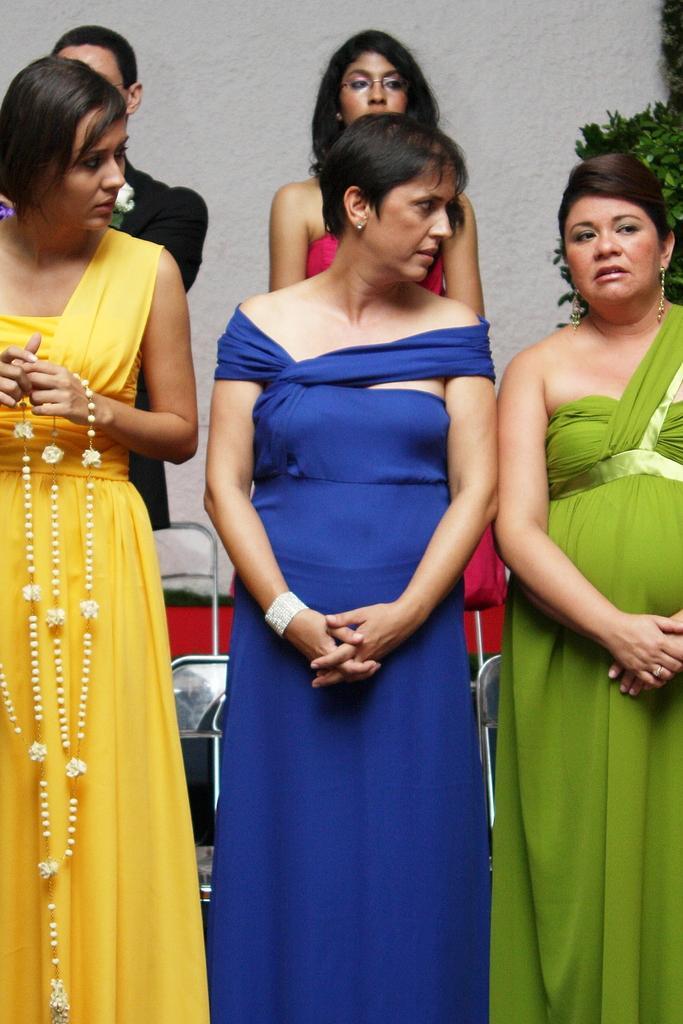Could you give a brief overview of what you see in this image? In the image I can see some women, among them a lady is holding the garland and also I can see some chairs and a plant. 